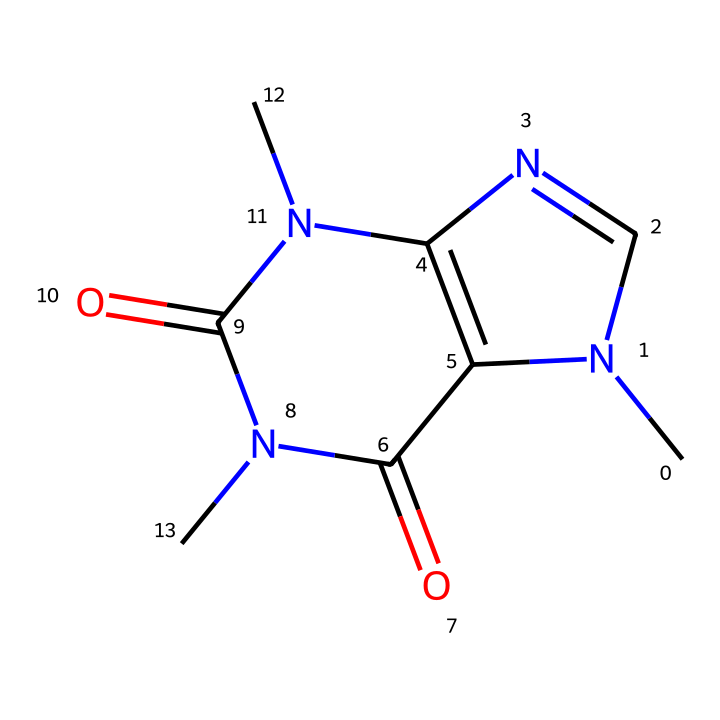What is the molecular formula of caffeine? The molecular formula can be determined by counting the number of each type of atom present in the SMILES representation. In this case, there are 8 carbon atoms (C), 10 hydrogen atoms (H), 4 nitrogen atoms (N), and 4 oxygen atoms (O). Thus, the formula is C8H10N4O2.
Answer: C8H10N4O2 How many nitrogen atoms are present in caffeine? By analyzing the SMILES representation, we can identify that there are 4 nitrogen atoms represented in the structure (noted by the ‘N’ symbols).
Answer: 4 What type of functional groups are present in caffeine? The structure includes carbonyl groups (C=O) and amine groups (C-N), which are characteristic functional groups in caffeine. Specifically, there are two carbonyl and multiple nitrogen-containing structures that classify it as an amine.
Answer: carbonyl and amine How many rings are present in the chemical structure of caffeine? To identify the rings, we assess the connections in the SMILES notation. The 'C=N' and other cyclic structures indicate that caffeine has two fused rings in its structure.
Answer: 2 Is caffeine a saturated or unsaturated compound? The presence of double bonds in the chemical structure, as observed in the SMILES notation with 'C=N' and 'C=O', indicates that caffeine is unsaturated.
Answer: unsaturated Which part of the caffeine structure contributes to its pharmacological effects? The nitrogen atoms are part of the structure that influence the interaction with biological targets (like neurotransmitter receptors), playing a crucial role in caffeine's stimulant effects.
Answer: nitrogen atoms 